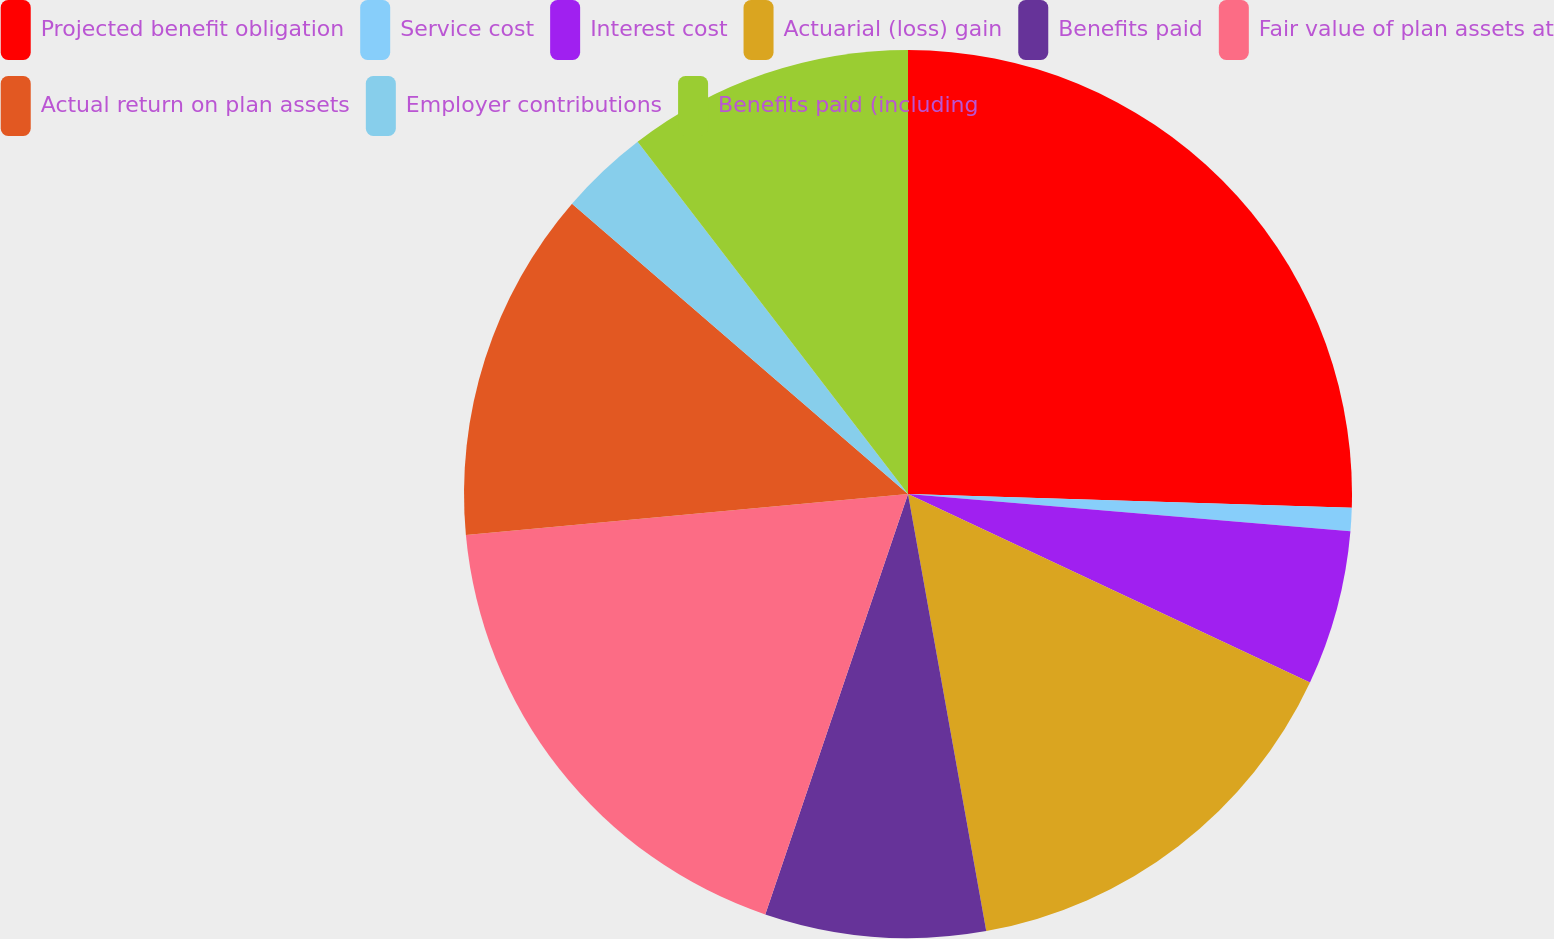Convert chart. <chart><loc_0><loc_0><loc_500><loc_500><pie_chart><fcel>Projected benefit obligation<fcel>Service cost<fcel>Interest cost<fcel>Actuarial (loss) gain<fcel>Benefits paid<fcel>Fair value of plan assets at<fcel>Actual return on plan assets<fcel>Employer contributions<fcel>Benefits paid (including<nl><fcel>25.49%<fcel>0.85%<fcel>5.64%<fcel>15.2%<fcel>8.03%<fcel>18.32%<fcel>12.81%<fcel>3.24%<fcel>10.42%<nl></chart> 